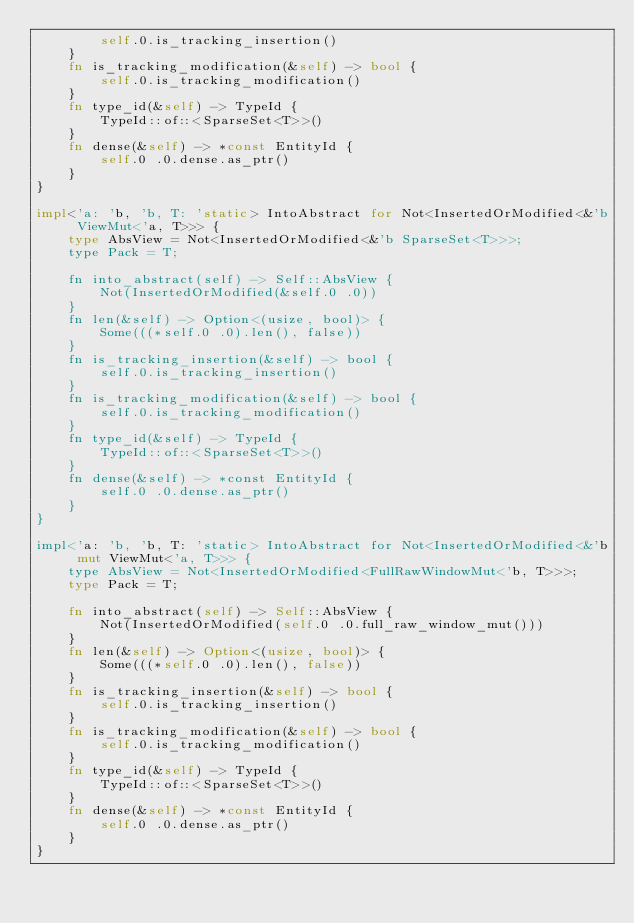Convert code to text. <code><loc_0><loc_0><loc_500><loc_500><_Rust_>        self.0.is_tracking_insertion()
    }
    fn is_tracking_modification(&self) -> bool {
        self.0.is_tracking_modification()
    }
    fn type_id(&self) -> TypeId {
        TypeId::of::<SparseSet<T>>()
    }
    fn dense(&self) -> *const EntityId {
        self.0 .0.dense.as_ptr()
    }
}

impl<'a: 'b, 'b, T: 'static> IntoAbstract for Not<InsertedOrModified<&'b ViewMut<'a, T>>> {
    type AbsView = Not<InsertedOrModified<&'b SparseSet<T>>>;
    type Pack = T;

    fn into_abstract(self) -> Self::AbsView {
        Not(InsertedOrModified(&self.0 .0))
    }
    fn len(&self) -> Option<(usize, bool)> {
        Some(((*self.0 .0).len(), false))
    }
    fn is_tracking_insertion(&self) -> bool {
        self.0.is_tracking_insertion()
    }
    fn is_tracking_modification(&self) -> bool {
        self.0.is_tracking_modification()
    }
    fn type_id(&self) -> TypeId {
        TypeId::of::<SparseSet<T>>()
    }
    fn dense(&self) -> *const EntityId {
        self.0 .0.dense.as_ptr()
    }
}

impl<'a: 'b, 'b, T: 'static> IntoAbstract for Not<InsertedOrModified<&'b mut ViewMut<'a, T>>> {
    type AbsView = Not<InsertedOrModified<FullRawWindowMut<'b, T>>>;
    type Pack = T;

    fn into_abstract(self) -> Self::AbsView {
        Not(InsertedOrModified(self.0 .0.full_raw_window_mut()))
    }
    fn len(&self) -> Option<(usize, bool)> {
        Some(((*self.0 .0).len(), false))
    }
    fn is_tracking_insertion(&self) -> bool {
        self.0.is_tracking_insertion()
    }
    fn is_tracking_modification(&self) -> bool {
        self.0.is_tracking_modification()
    }
    fn type_id(&self) -> TypeId {
        TypeId::of::<SparseSet<T>>()
    }
    fn dense(&self) -> *const EntityId {
        self.0 .0.dense.as_ptr()
    }
}
</code> 